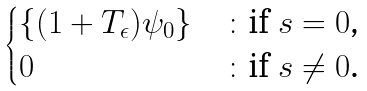Convert formula to latex. <formula><loc_0><loc_0><loc_500><loc_500>\begin{cases} \{ ( 1 + T _ { \epsilon } ) \psi _ { 0 } \} & \colon \text {if $s=0$,} \\ 0 & \colon \text {if $s\neq 0$.} \end{cases}</formula> 